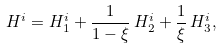<formula> <loc_0><loc_0><loc_500><loc_500>H ^ { i } = H ^ { i } _ { 1 } + \frac { 1 } { 1 - \xi } \, H ^ { i } _ { 2 } + \frac { 1 } { \xi } \, H ^ { i } _ { 3 } ,</formula> 